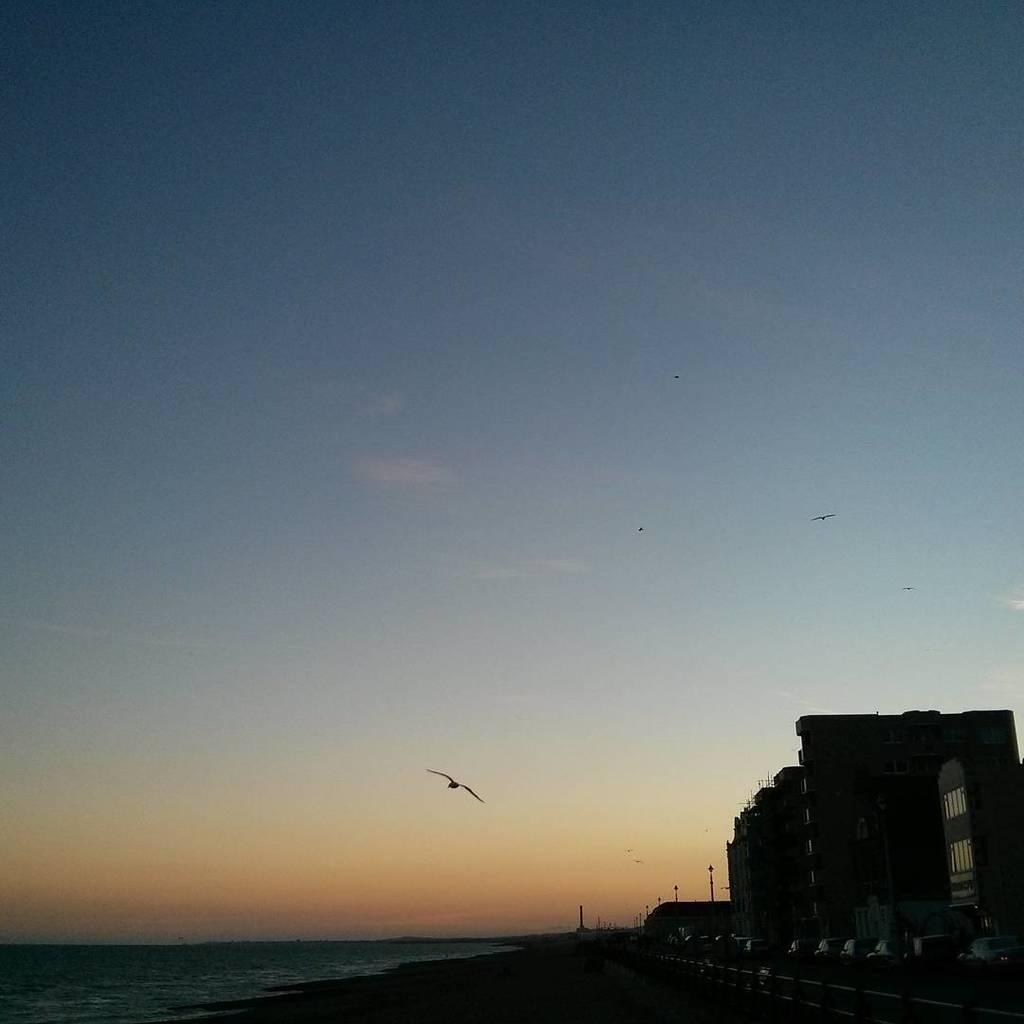What type of structures can be seen in the image? There are buildings in the image. What is located near the buildings? There are poles near the buildings. What natural element is visible in the image? There is water visible in the image. What can be seen in the sky in the background of the image? There are birds flying in the sky in the background of the image. What is visible in the background of the image? The sky is visible in the background of the image. What type of park can be seen in the image? There is no park present in the image. What smell is associated with the image? The image does not convey any specific smell. 